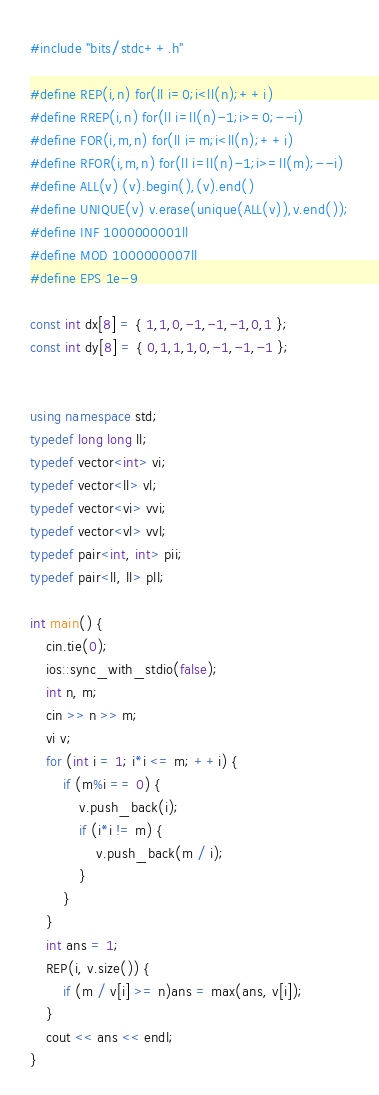Convert code to text. <code><loc_0><loc_0><loc_500><loc_500><_C++_>#include "bits/stdc++.h"

#define REP(i,n) for(ll i=0;i<ll(n);++i)
#define RREP(i,n) for(ll i=ll(n)-1;i>=0;--i)
#define FOR(i,m,n) for(ll i=m;i<ll(n);++i)
#define RFOR(i,m,n) for(ll i=ll(n)-1;i>=ll(m);--i)
#define ALL(v) (v).begin(),(v).end()
#define UNIQUE(v) v.erase(unique(ALL(v)),v.end());
#define INF 1000000001ll
#define MOD 1000000007ll
#define EPS 1e-9

const int dx[8] = { 1,1,0,-1,-1,-1,0,1 };
const int dy[8] = { 0,1,1,1,0,-1,-1,-1 };


using namespace std;
typedef long long ll;
typedef vector<int> vi;
typedef vector<ll> vl;
typedef vector<vi> vvi;
typedef vector<vl> vvl;
typedef pair<int, int> pii;
typedef pair<ll, ll> pll;

int main() {
	cin.tie(0);
	ios::sync_with_stdio(false);
	int n, m;
	cin >> n >> m;
	vi v;
	for (int i = 1; i*i <= m; ++i) {
		if (m%i == 0) {
			v.push_back(i);
			if (i*i != m) {
				v.push_back(m / i);
			}
		}
	}
	int ans = 1;
	REP(i, v.size()) {
		if (m / v[i] >= n)ans = max(ans, v[i]);
	}
	cout << ans << endl;
}</code> 